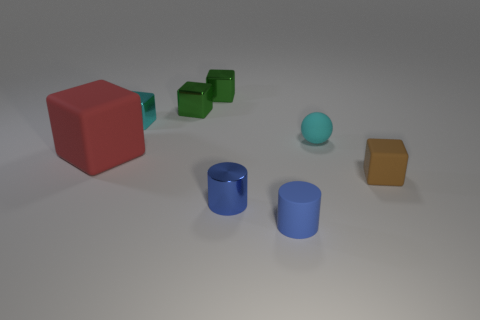Subtract all brown blocks. How many blocks are left? 4 Subtract all cyan cubes. How many cubes are left? 4 Subtract 1 blocks. How many blocks are left? 4 Subtract all gray blocks. Subtract all brown cylinders. How many blocks are left? 5 Add 2 brown matte objects. How many objects exist? 10 Subtract all spheres. How many objects are left? 7 Add 4 tiny metal cylinders. How many tiny metal cylinders exist? 5 Subtract 0 purple spheres. How many objects are left? 8 Subtract all tiny green blocks. Subtract all small green things. How many objects are left? 4 Add 6 small brown rubber blocks. How many small brown rubber blocks are left? 7 